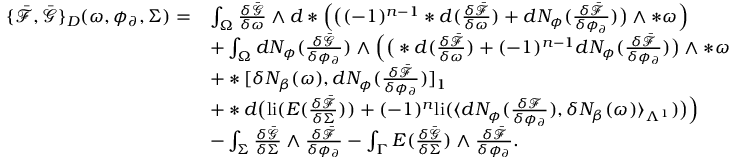<formula> <loc_0><loc_0><loc_500><loc_500>\begin{array} { r l } { \{ \bar { \mathcal { F } } , \bar { \mathcal { G } } \} _ { D } ( \omega , \phi _ { \partial } , \Sigma ) = } & { \int _ { \Omega } \frac { \delta \bar { \mathcal { G } } } { \delta \omega } \wedge d \ast \left ( \left ( ( - 1 ) ^ { n - 1 } \ast d ( \frac { \delta \bar { \mathcal { F } } } { \delta \omega } ) + d N _ { \phi } ( \frac { \delta \bar { \mathcal { F } } } { \delta \phi _ { \partial } } ) \right ) \wedge \ast \omega \right ) } \\ & { + \int _ { \Omega } d N _ { \phi } ( \frac { \delta \bar { \mathcal { G } } } { \delta \phi _ { \partial } } ) \wedge \left ( \left ( \ast d ( \frac { \delta \bar { \mathcal { F } } } { \delta \omega } ) + ( - 1 ) ^ { n - 1 } d N _ { \phi } ( \frac { \delta \bar { \mathcal { F } } } { \delta \phi _ { \partial } } ) \right ) \wedge \ast \omega } \\ & { + \ast [ \delta N _ { \beta } ( \omega ) , d N _ { \phi } ( \frac { \delta \bar { \mathcal { F } } } { \delta \phi _ { \partial } } ) ] _ { 1 } } \\ & { + \ast d \left ( l i ( E ( \frac { \delta \bar { \mathcal { F } } } { \delta \Sigma } ) ) + ( - 1 ) ^ { n } l i ( \langle d N _ { \phi } ( \frac { \delta \mathcal { F } } { \delta \phi _ { \partial } } ) , \delta N _ { \beta } ( \omega ) \rangle _ { \Lambda ^ { 1 } } ) \right ) \right ) } \\ & { - \int _ { \Sigma } \frac { \delta \bar { \mathcal { G } } } { \delta \Sigma } \wedge \frac { \delta \bar { \mathcal { F } } } { \delta \phi _ { \partial } } - \int _ { \Gamma } E ( \frac { \delta \bar { \mathcal { G } } } { \delta \Sigma } ) \wedge \frac { \delta \bar { \mathcal { F } } } { \delta \phi _ { \partial } } . } \end{array}</formula> 